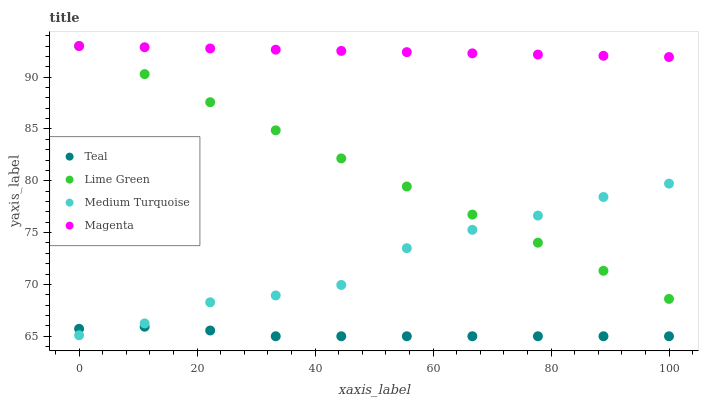Does Teal have the minimum area under the curve?
Answer yes or no. Yes. Does Magenta have the maximum area under the curve?
Answer yes or no. Yes. Does Lime Green have the minimum area under the curve?
Answer yes or no. No. Does Lime Green have the maximum area under the curve?
Answer yes or no. No. Is Magenta the smoothest?
Answer yes or no. Yes. Is Medium Turquoise the roughest?
Answer yes or no. Yes. Is Lime Green the smoothest?
Answer yes or no. No. Is Lime Green the roughest?
Answer yes or no. No. Does Teal have the lowest value?
Answer yes or no. Yes. Does Lime Green have the lowest value?
Answer yes or no. No. Does Lime Green have the highest value?
Answer yes or no. Yes. Does Medium Turquoise have the highest value?
Answer yes or no. No. Is Teal less than Magenta?
Answer yes or no. Yes. Is Magenta greater than Teal?
Answer yes or no. Yes. Does Medium Turquoise intersect Teal?
Answer yes or no. Yes. Is Medium Turquoise less than Teal?
Answer yes or no. No. Is Medium Turquoise greater than Teal?
Answer yes or no. No. Does Teal intersect Magenta?
Answer yes or no. No. 